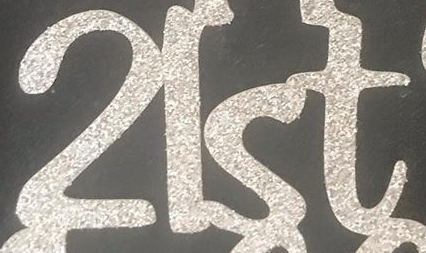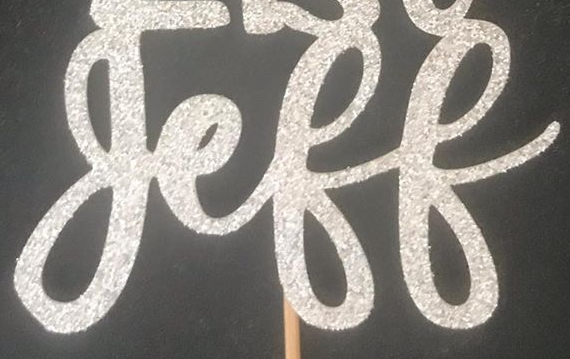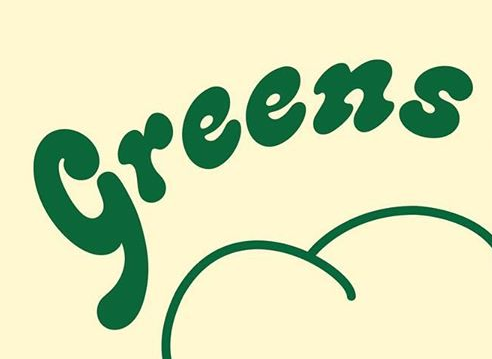What words can you see in these images in sequence, separated by a semicolon? 2lst; geff; Greens 